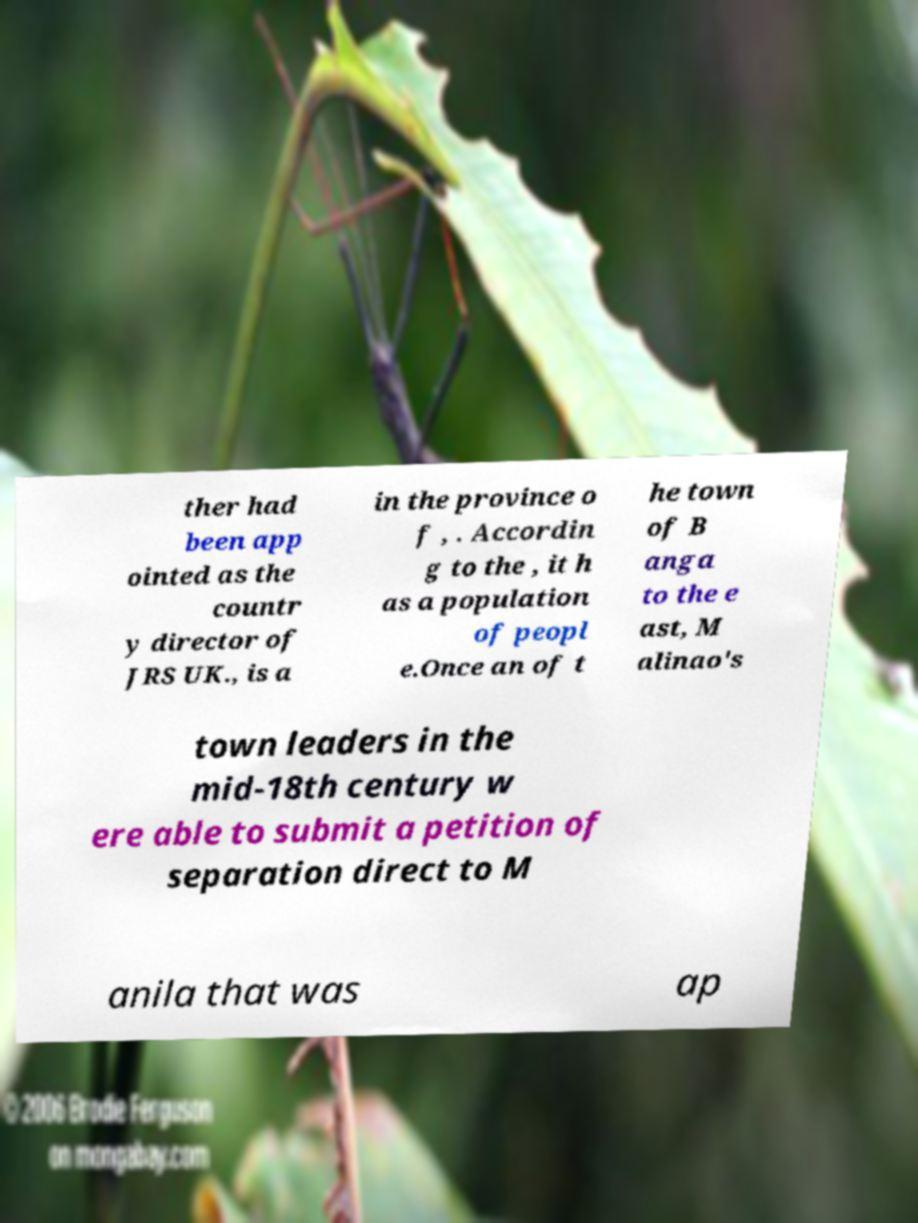I need the written content from this picture converted into text. Can you do that? ther had been app ointed as the countr y director of JRS UK., is a in the province o f , . Accordin g to the , it h as a population of peopl e.Once an of t he town of B anga to the e ast, M alinao's town leaders in the mid-18th century w ere able to submit a petition of separation direct to M anila that was ap 